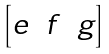Convert formula to latex. <formula><loc_0><loc_0><loc_500><loc_500>\begin{bmatrix} e & f & g \\ \end{bmatrix}</formula> 